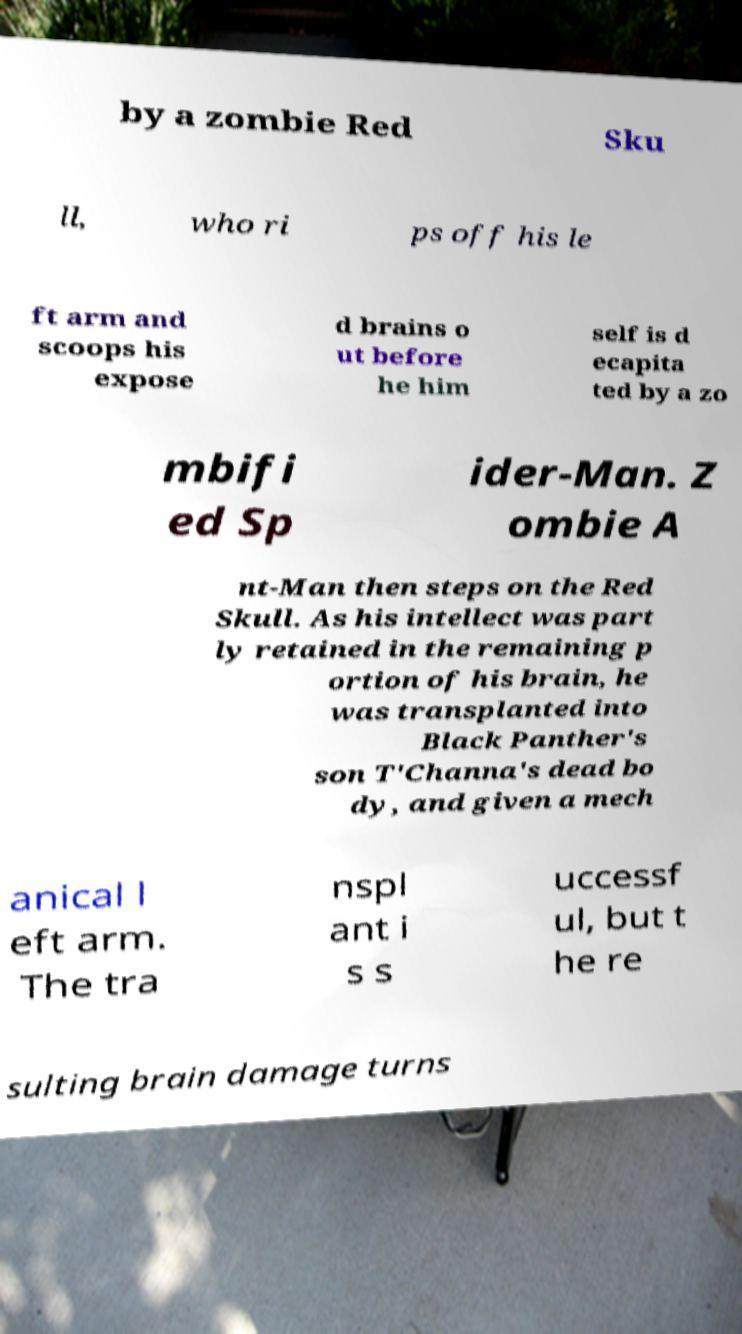Can you read and provide the text displayed in the image?This photo seems to have some interesting text. Can you extract and type it out for me? by a zombie Red Sku ll, who ri ps off his le ft arm and scoops his expose d brains o ut before he him self is d ecapita ted by a zo mbifi ed Sp ider-Man. Z ombie A nt-Man then steps on the Red Skull. As his intellect was part ly retained in the remaining p ortion of his brain, he was transplanted into Black Panther's son T'Channa's dead bo dy, and given a mech anical l eft arm. The tra nspl ant i s s uccessf ul, but t he re sulting brain damage turns 